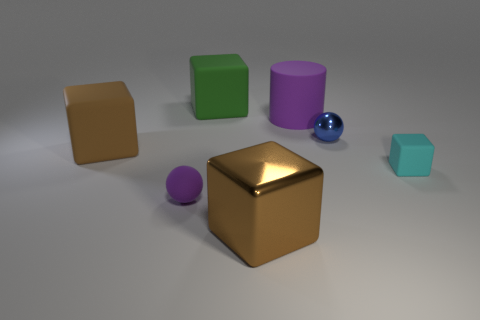Subtract all blocks. How many objects are left? 3 Add 3 big shiny cubes. How many objects exist? 10 Subtract all large brown things. Subtract all tiny purple matte balls. How many objects are left? 4 Add 4 tiny shiny balls. How many tiny shiny balls are left? 5 Add 7 small rubber objects. How many small rubber objects exist? 9 Subtract 0 brown balls. How many objects are left? 7 